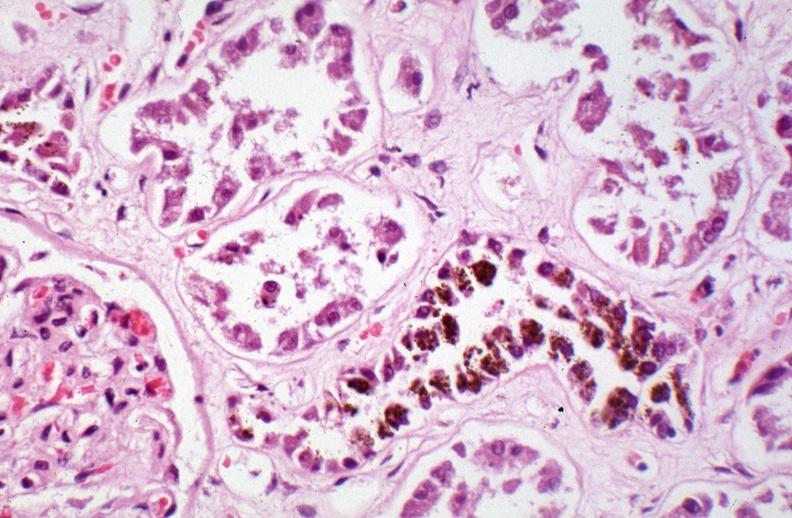what is hemosiderosis caused?
Answer the question using a single word or phrase. By numerous blood transfusions 